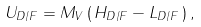Convert formula to latex. <formula><loc_0><loc_0><loc_500><loc_500>U _ { D / F } = M _ { V } \, ( \, H _ { D / F } - L _ { D / F } \, ) \, ,</formula> 